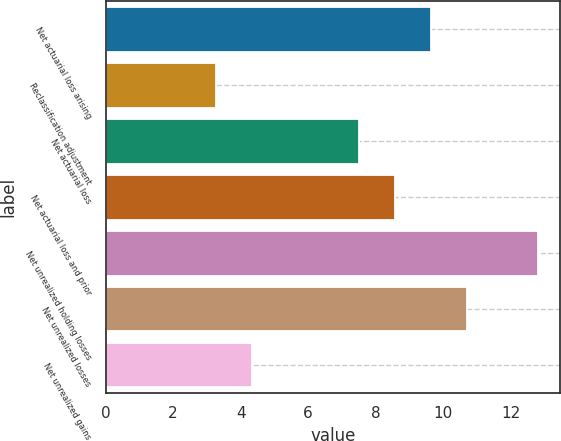Convert chart to OTSL. <chart><loc_0><loc_0><loc_500><loc_500><bar_chart><fcel>Net actuarial loss arising<fcel>Reclassification adjustment<fcel>Net actuarial loss<fcel>Net actuarial loss and prior<fcel>Net unrealized holding losses<fcel>Net unrealized losses<fcel>Net unrealized gains<nl><fcel>9.64<fcel>3.28<fcel>7.52<fcel>8.58<fcel>12.82<fcel>10.7<fcel>4.34<nl></chart> 